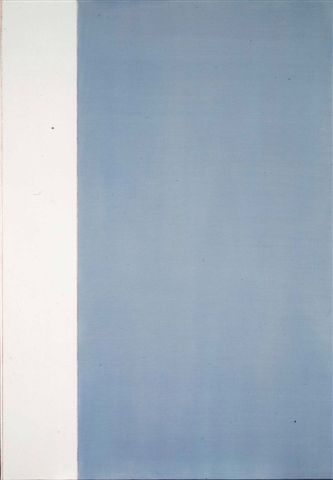What is this photo about? The image portrays an abstract art piece characterized by its minimalistic style. It is divided into two distinctive sections: a white segment on the left and a blue segment on the right. The white section exudes a sense of purity and emptiness, while the blue section, which features a gradient effect lightening towards the top, gives a sense of depth or upward movement. The stark contrast between the two sections may symbolize a balance or dichotomy between different states or elements. The simplicity and the use of gradient add to the abstract and minimalist nature of the art. 